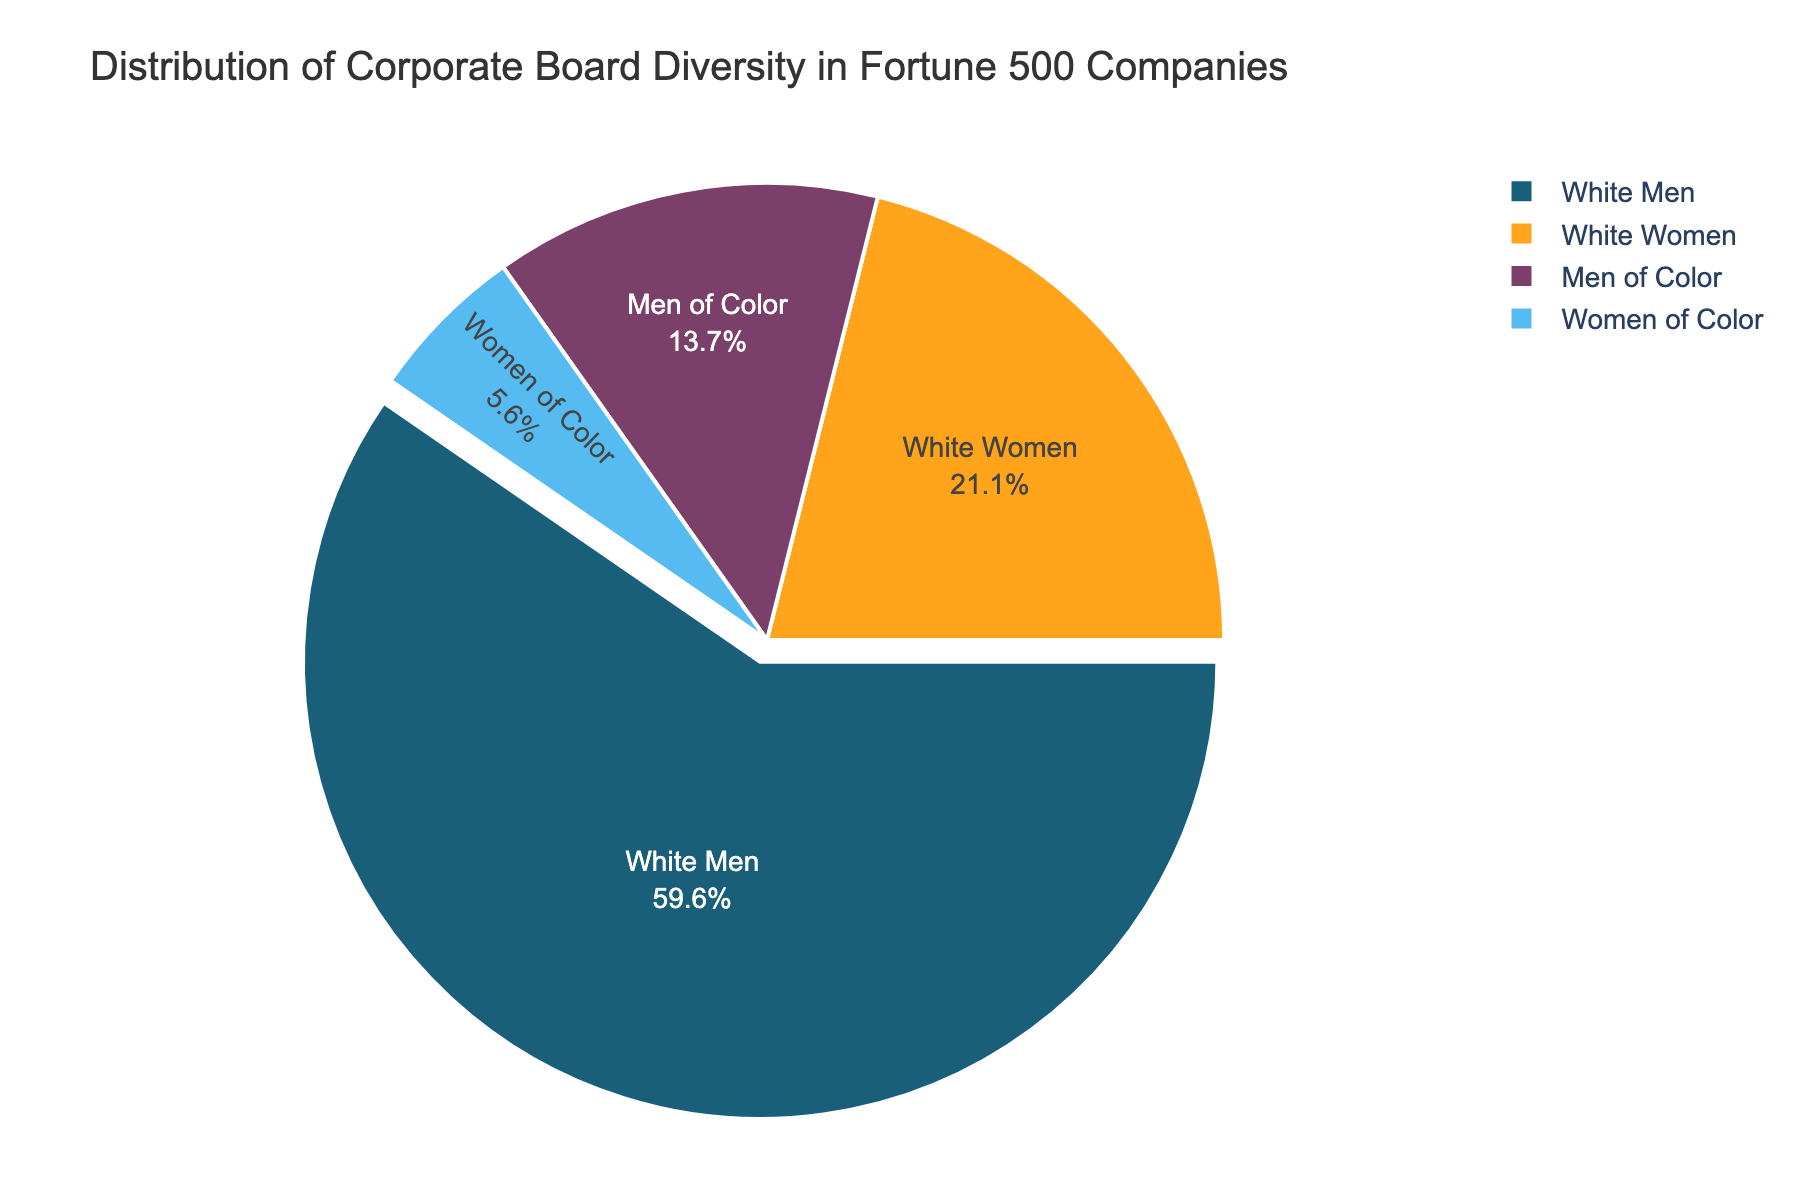What is the largest category in the distribution of corporate board diversity? The figure shows a pie chart with different segments representing different categories. The largest segment corresponds to "White Men"
Answer: White Men What percentage of corporate boards are composed of White Women and Women of Color combined? According to the pie chart, "White Women" make up 21.1% and "Women of Color" make up 5.6%. Adding these percentages: 21.1 + 5.6 = 26.7%
Answer: 26.7% Which category has the smallest representation on corporate boards? The pie chart segments show that the smallest category is "Women of Color" with 5.6%
Answer: Women of Color How many times larger is the representation of White Men compared to Women of Color? The pie chart shows that "White Men" hold 59.6% and "Women of Color" hold 5.6%. Dividing these gives: 59.6 / 5.6 ≈ 10.64
Answer: About 10.64 times What is the color associated with the segment for Men of Color in the pie chart? The pie chart uses different colors for each category. The segment for "Men of Color" is represented by a purple shade (which appears in the pie chart)
Answer: Purple What percent more do White Men occupy than White Women on corporate boards? The representation of "White Men" is 59.6% and "White Women" is 21.1%. The difference is found by subtracting: 59.6 - 21.1 = 38.5%
Answer: 38.5% Combine the representation of all men irrespective of color. What is the total percentage? The pie chart shows "White Men" at 59.6% and "Men of Color" at 13.7%. Adding these figures: 59.6 + 13.7 = 73.3%
Answer: 73.3% Which two categories together make up less than 20% of corporate boards? The pie chart shows "Men of Color" at 13.7% and "Women of Color" at 5.6%. Adding these figures: 13.7 + 5.6 = 19.3%, which is less than 20%
Answer: Men of Color and Women of Color Is the representation of White Women more than three times that of Women of Color? The pie chart shows that "White Women" are at 21.1% and "Women of Color" are at 5.6%. Calculating three times 5.6 gives: 5.6 * 3 = 16.8%. Since 21.1% is greater than 16.8%, the representation is indeed more than three times
Answer: Yes 